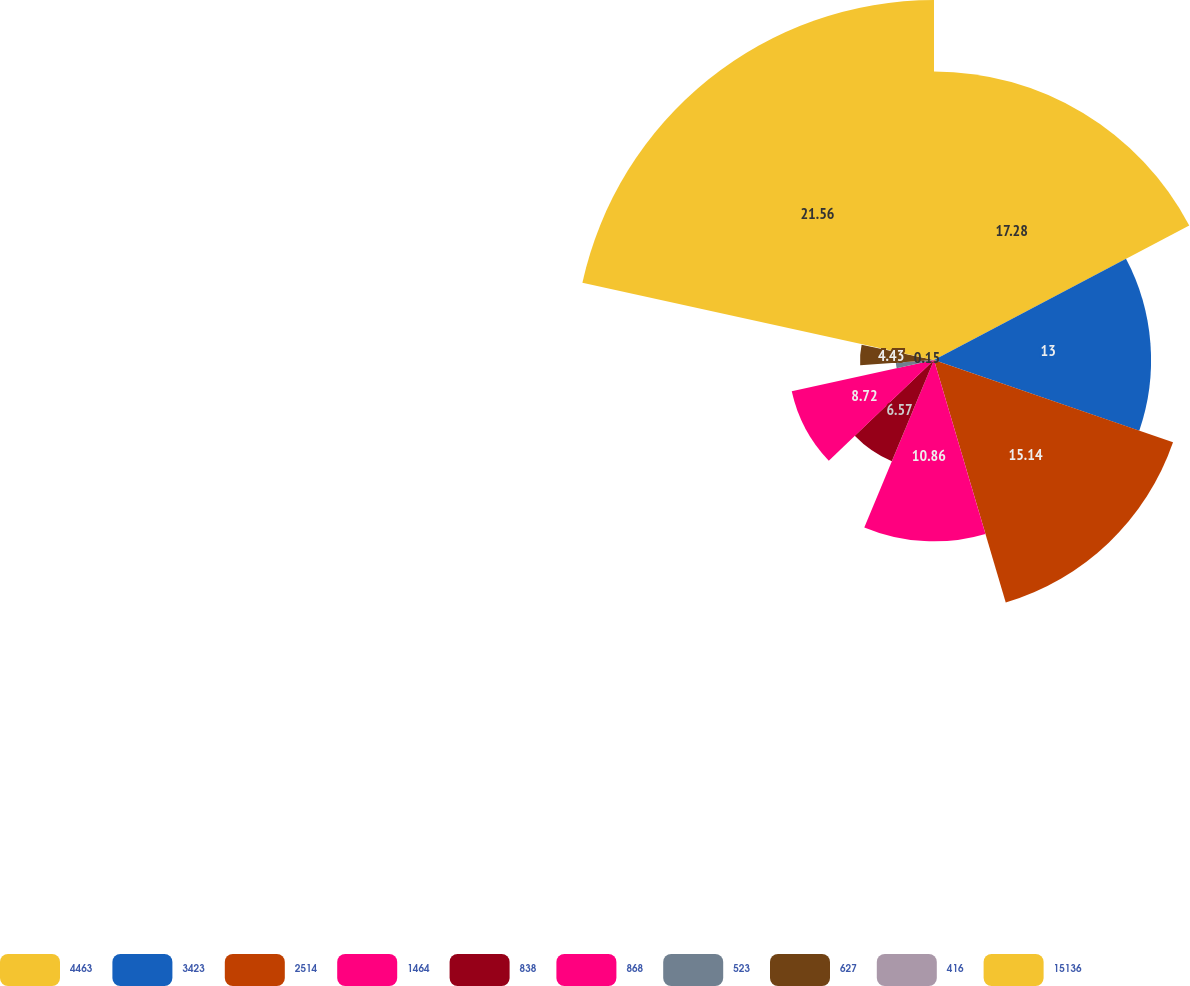Convert chart. <chart><loc_0><loc_0><loc_500><loc_500><pie_chart><fcel>4463<fcel>3423<fcel>2514<fcel>1464<fcel>838<fcel>868<fcel>523<fcel>627<fcel>416<fcel>15136<nl><fcel>17.28%<fcel>13.0%<fcel>15.14%<fcel>10.86%<fcel>6.57%<fcel>8.72%<fcel>2.29%<fcel>4.43%<fcel>0.15%<fcel>21.56%<nl></chart> 